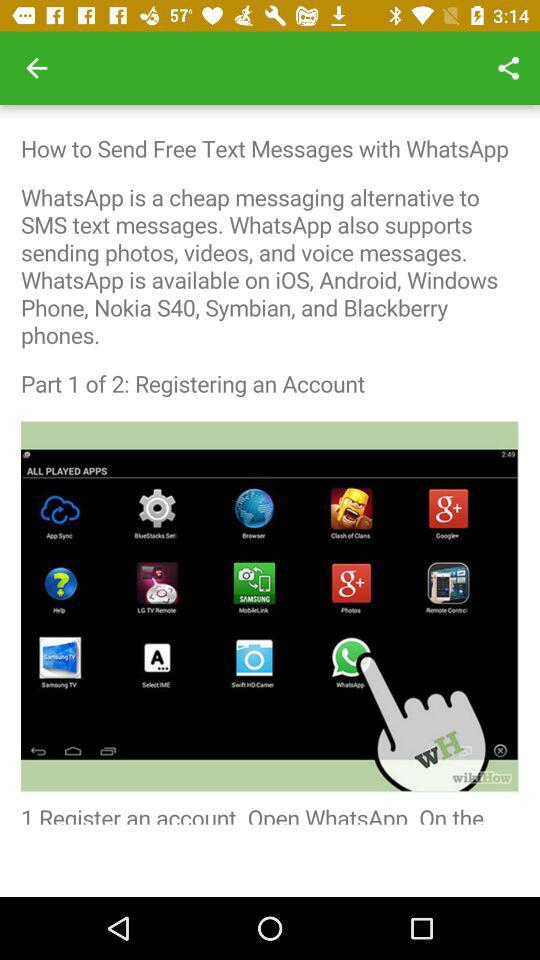WhatsApp is available on which phones? WhatsApp is available on "iOS", "Android", "Windows Phones", "Nokia S40", "Symbian", and "Blackberry". 